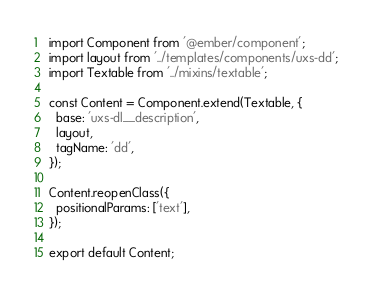<code> <loc_0><loc_0><loc_500><loc_500><_JavaScript_>import Component from '@ember/component';
import layout from '../templates/components/uxs-dd';
import Textable from '../mixins/textable';

const Content = Component.extend(Textable, {
  base: 'uxs-dl__description',
  layout,
  tagName: 'dd',
});

Content.reopenClass({
  positionalParams: ['text'],
});

export default Content;</code> 